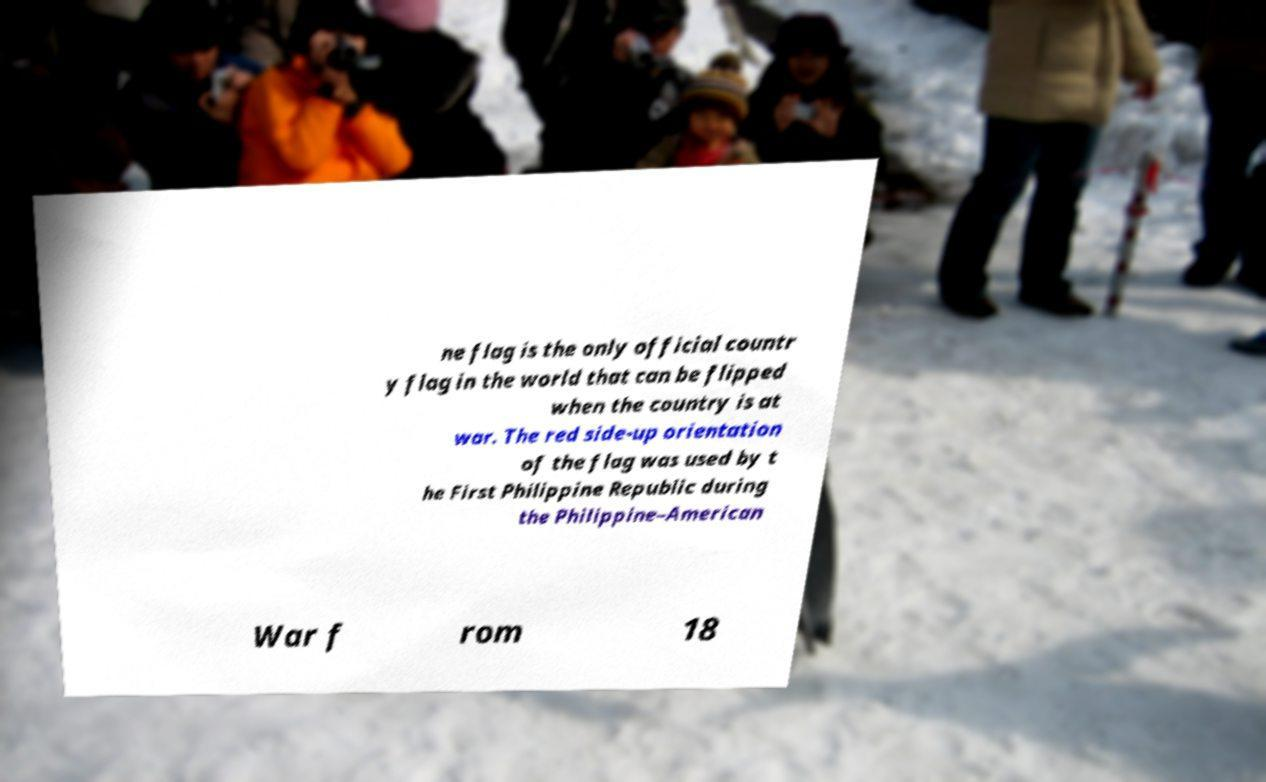Please identify and transcribe the text found in this image. ne flag is the only official countr y flag in the world that can be flipped when the country is at war. The red side-up orientation of the flag was used by t he First Philippine Republic during the Philippine–American War f rom 18 